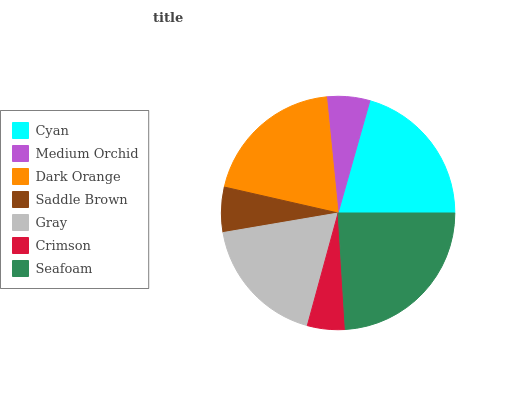Is Crimson the minimum?
Answer yes or no. Yes. Is Seafoam the maximum?
Answer yes or no. Yes. Is Medium Orchid the minimum?
Answer yes or no. No. Is Medium Orchid the maximum?
Answer yes or no. No. Is Cyan greater than Medium Orchid?
Answer yes or no. Yes. Is Medium Orchid less than Cyan?
Answer yes or no. Yes. Is Medium Orchid greater than Cyan?
Answer yes or no. No. Is Cyan less than Medium Orchid?
Answer yes or no. No. Is Gray the high median?
Answer yes or no. Yes. Is Gray the low median?
Answer yes or no. Yes. Is Cyan the high median?
Answer yes or no. No. Is Seafoam the low median?
Answer yes or no. No. 